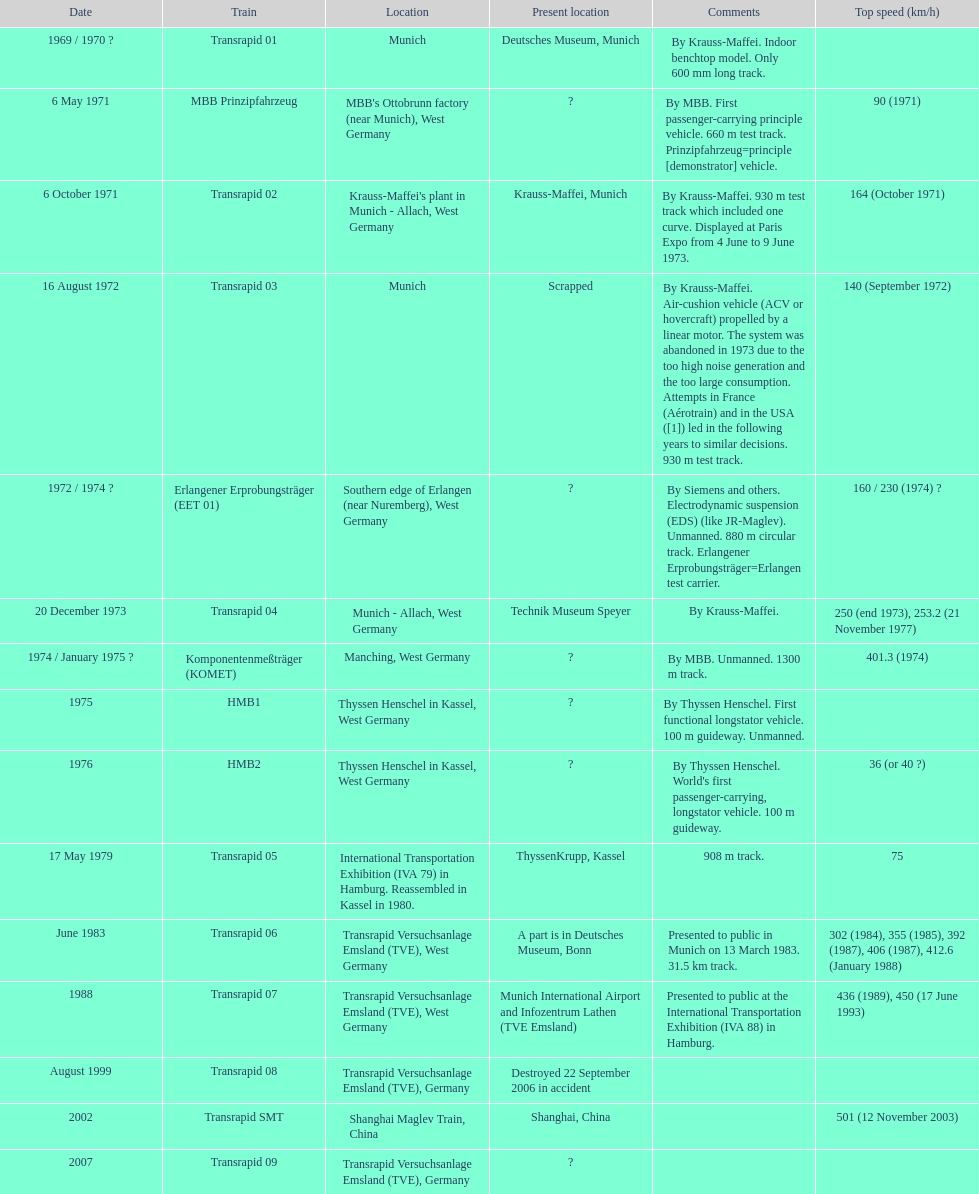After the erlangener erprobungsträger, what train was developed? Transrapid 04. 